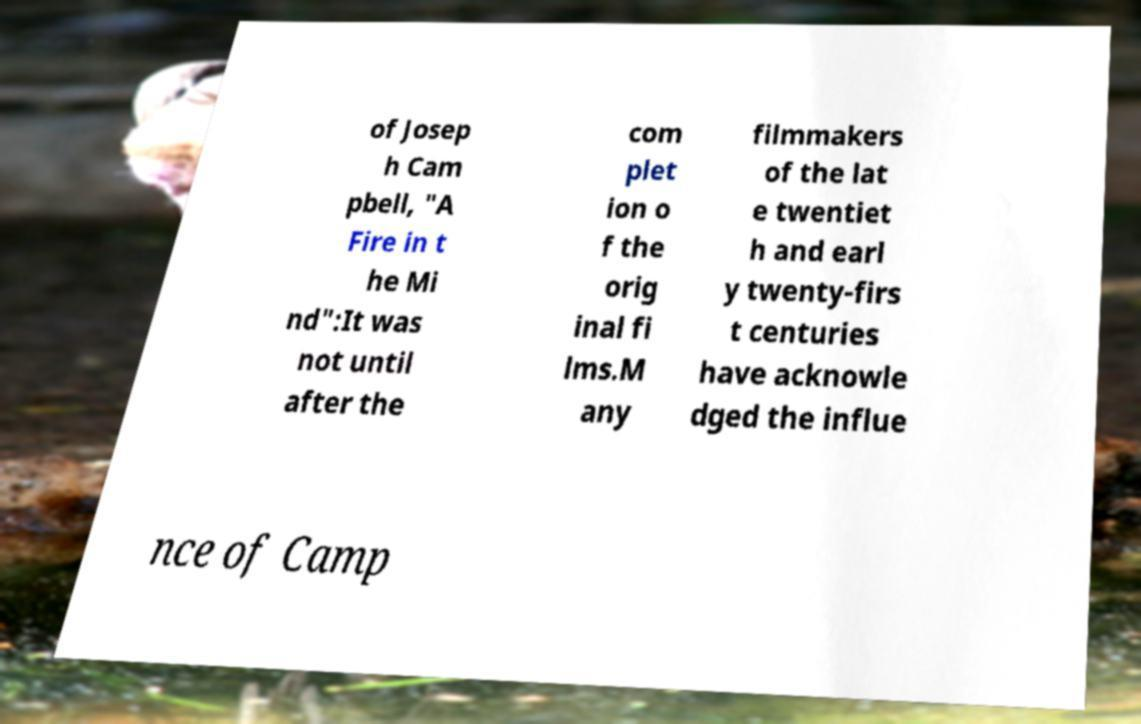Please read and relay the text visible in this image. What does it say? of Josep h Cam pbell, "A Fire in t he Mi nd":It was not until after the com plet ion o f the orig inal fi lms.M any filmmakers of the lat e twentiet h and earl y twenty-firs t centuries have acknowle dged the influe nce of Camp 